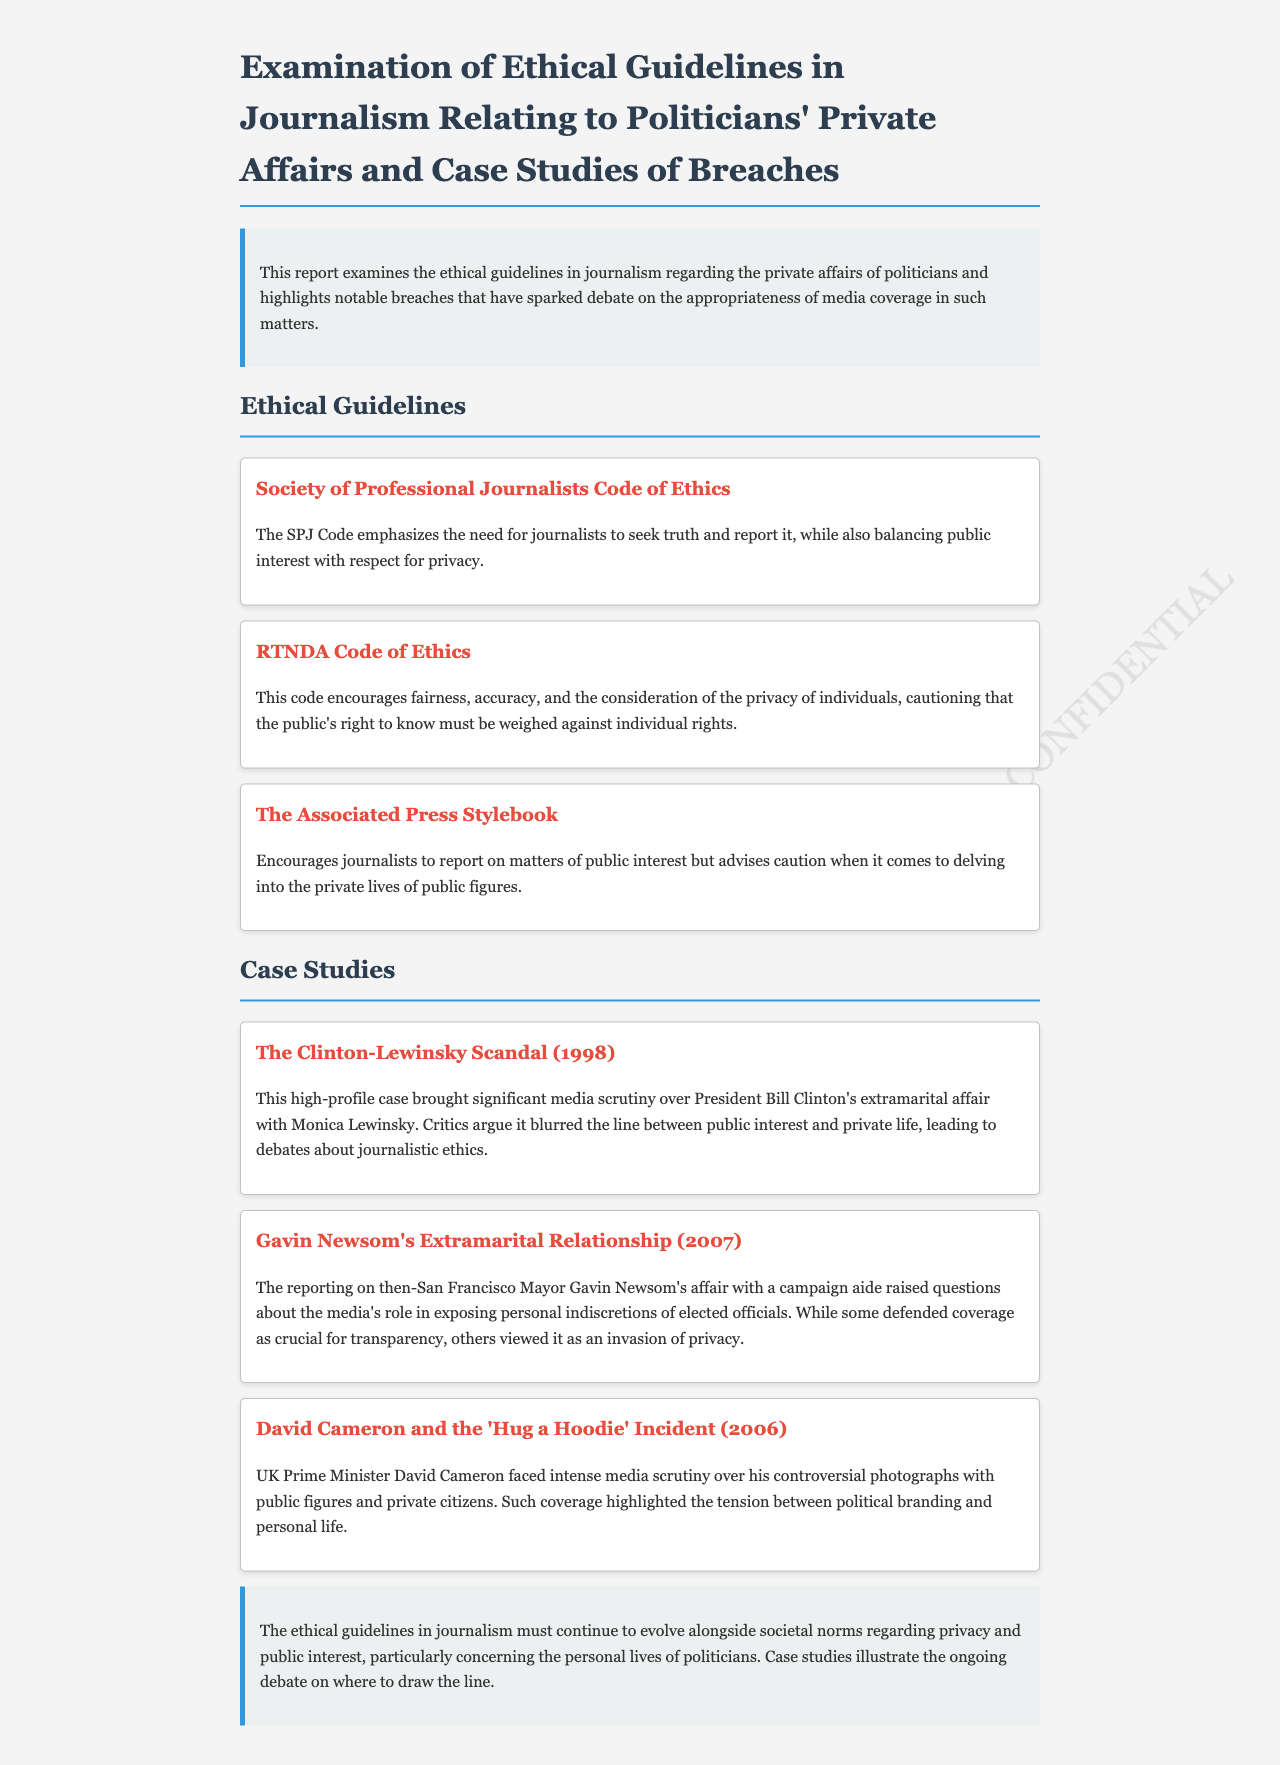What is the title of the report? The title of the report is mentioned at the beginning and summarizes the key focus areas, including ethical guidelines and breaches in journalism regarding politicians' private affairs.
Answer: Examination of Ethical Guidelines in Journalism Relating to Politicians' Private Affairs and Case Studies of Breaches What organization emphasizes journalists to seek truth? The organization that emphasizes this principle is detailed in the ethical guidelines section of the report.
Answer: Society of Professional Journalists What year did the Clinton-Lewinsky scandal occur? The report provides the year when this significant case received major media attention.
Answer: 1998 Which code advises caution about delving into public figures' private lives? This code is mentioned in the ethical guidelines and directly addresses the issue of privacy.
Answer: The Associated Press Stylebook What incident involved David Cameron in 2006? The report describes a specific incident regarding the UK Prime Minister from 2006 and its media implications.
Answer: 'Hug a Hoodie' Incident What key issue does the report highlight in the conclusion? The conclusion summarizes the central issue that journalists face as societal norms change over time.
Answer: Ongoing debate on privacy and public interest How many case studies are presented in the report? The report lists a specific number of case studies that illustrate breaches of ethical guidelines in journalism.
Answer: Three What does the RTNDA Code of Ethics emphasize? The RTNDA Code of Ethics is discussed in the report regarding its stance on privacy versus public knowledge.
Answer: Fairness and accuracy What is a primary concern raised about media coverage of politicians' affairs? This concern is a theme explored throughout the report and specifically during discussions of case studies.
Answer: Invasion of privacy 